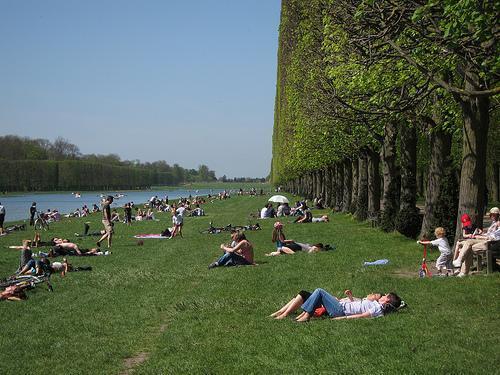How many umbrellas are shown?
Give a very brief answer. 1. 